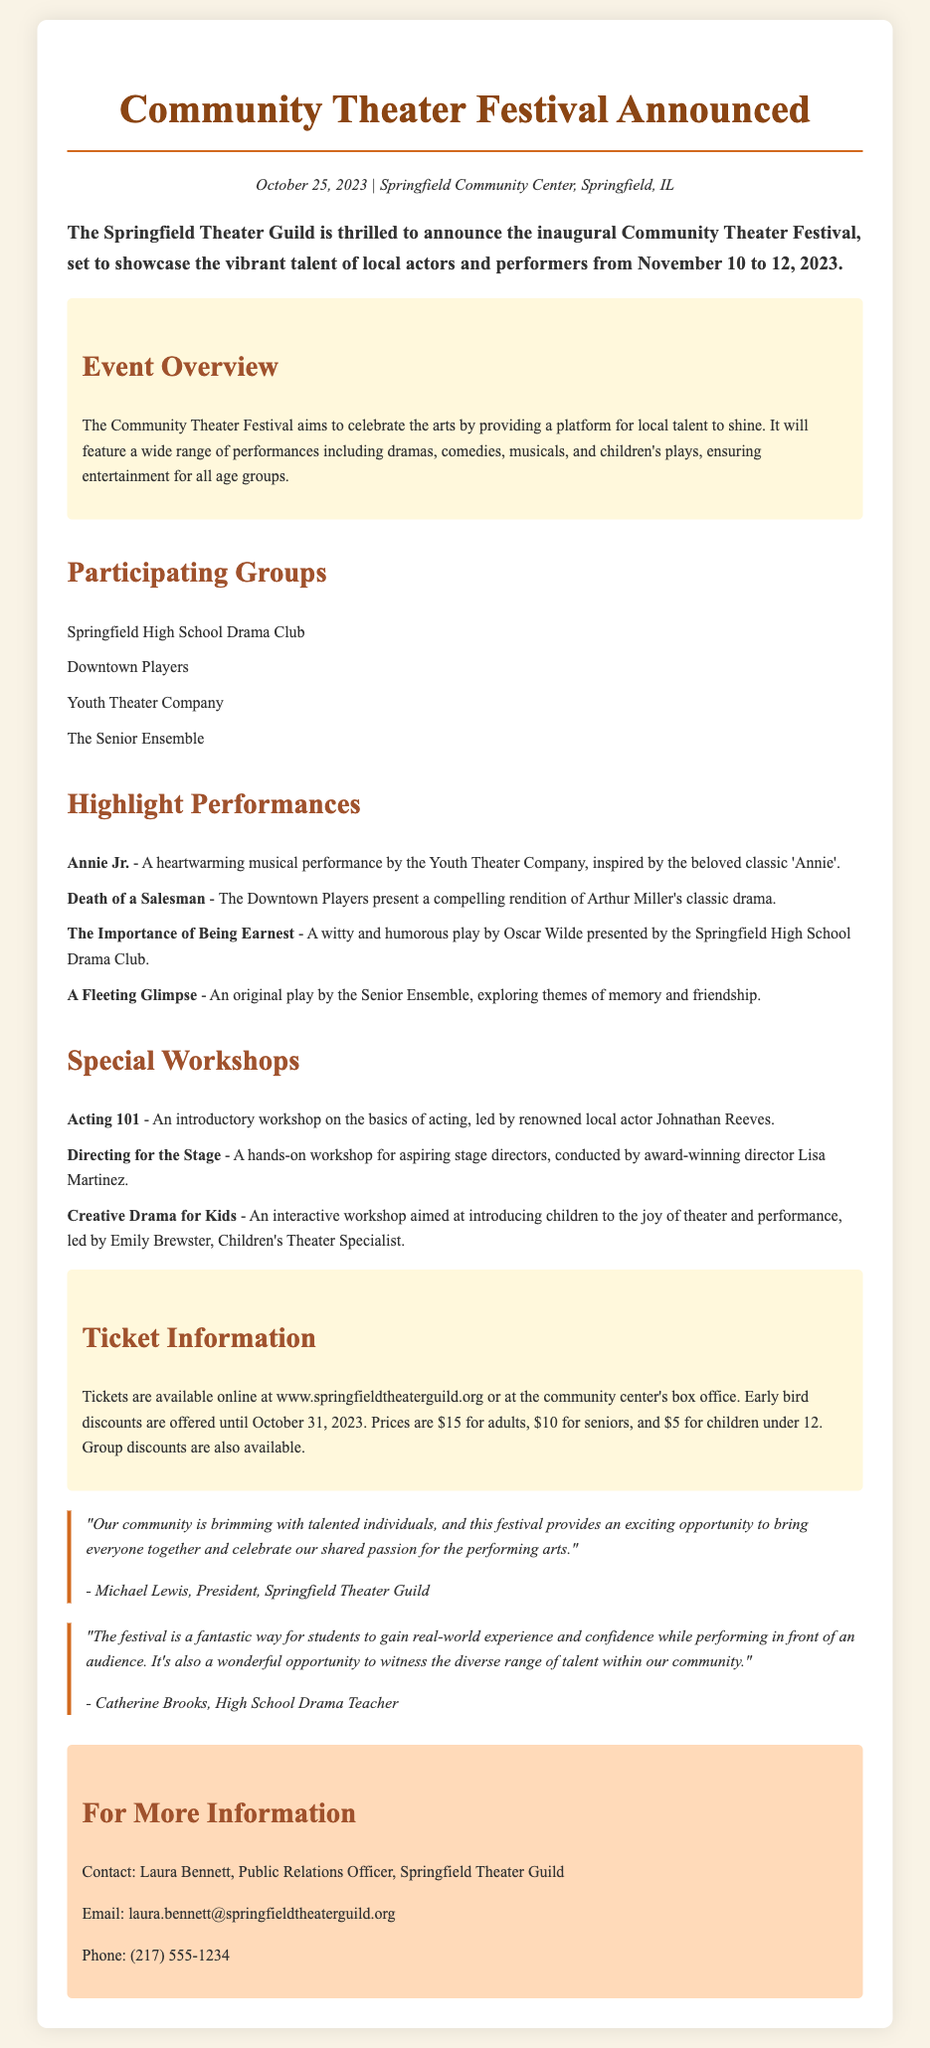What are the dates of the festival? The festival is scheduled to take place from November 10 to 12, 2023.
Answer: November 10 to 12, 2023 Who is the renowned local actor leading the "Acting 101" workshop? The document states that Johnathan Reeves is the local actor leading the workshop.
Answer: Johnathan Reeves What is the ticket price for children under 12? According to the ticket information, the price for children under 12 is $5.
Answer: $5 Which performance is by the Youth Theater Company? The document mentions "Annie Jr." is performed by the Youth Theater Company.
Answer: Annie Jr What type of performance is "Death of a Salesman"? The document describes "Death of a Salesman" as a classic drama presented by the Downtown Players.
Answer: Classic drama What opportunity does the festival provide for students? The High School Drama Teacher's quote indicates that the festival provides real-world experience and confidence while performing.
Answer: Real-world experience and confidence What is the main goal of the Community Theater Festival? The festival aims to celebrate the arts by providing a platform for local talent to shine.
Answer: Celebrate the arts Who should be contacted for more information about the festival? The document specifies that Laura Bennett is the contact for more information regarding the festival.
Answer: Laura Bennett What is the location of the festival? The event will take place at Springfield Community Center, Springfield, IL.
Answer: Springfield Community Center, Springfield, IL 